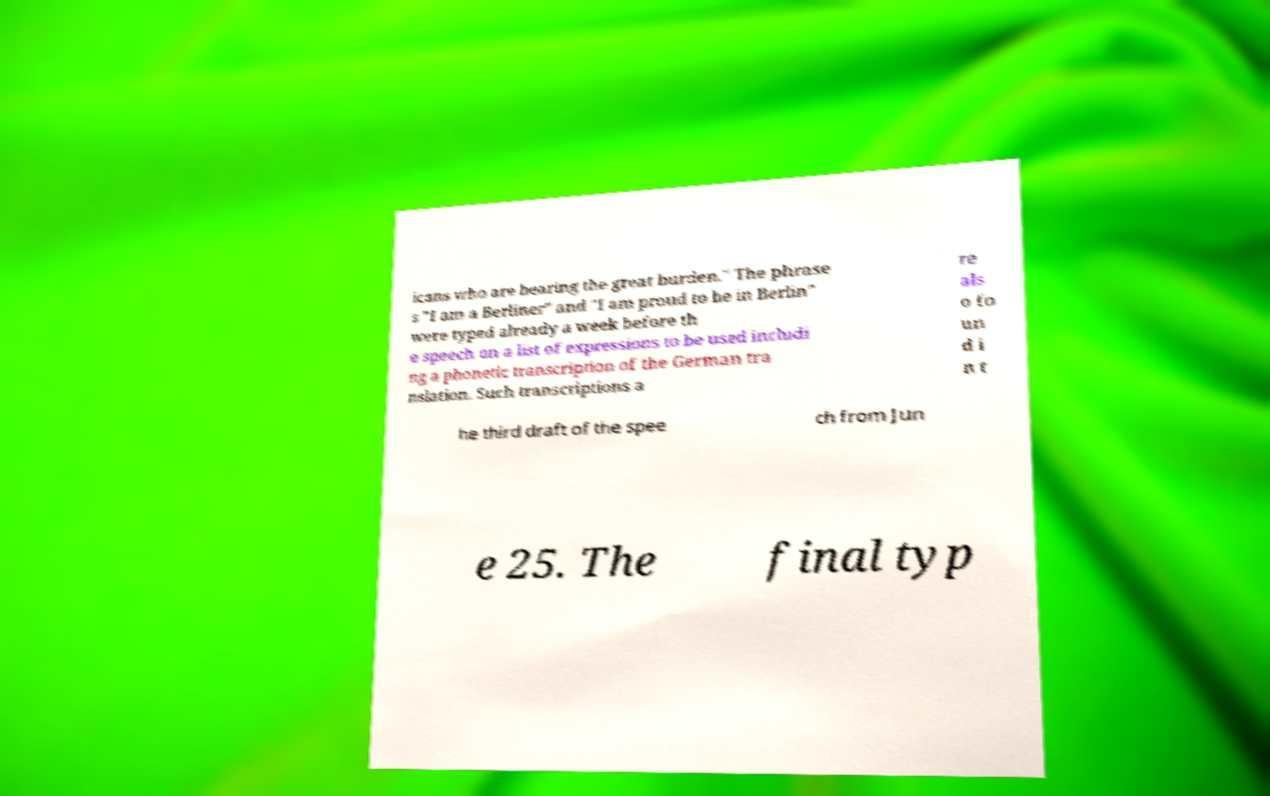There's text embedded in this image that I need extracted. Can you transcribe it verbatim? icans who are bearing the great burden." The phrase s "I am a Berliner" and "I am proud to be in Berlin" were typed already a week before th e speech on a list of expressions to be used includi ng a phonetic transcription of the German tra nslation. Such transcriptions a re als o fo un d i n t he third draft of the spee ch from Jun e 25. The final typ 